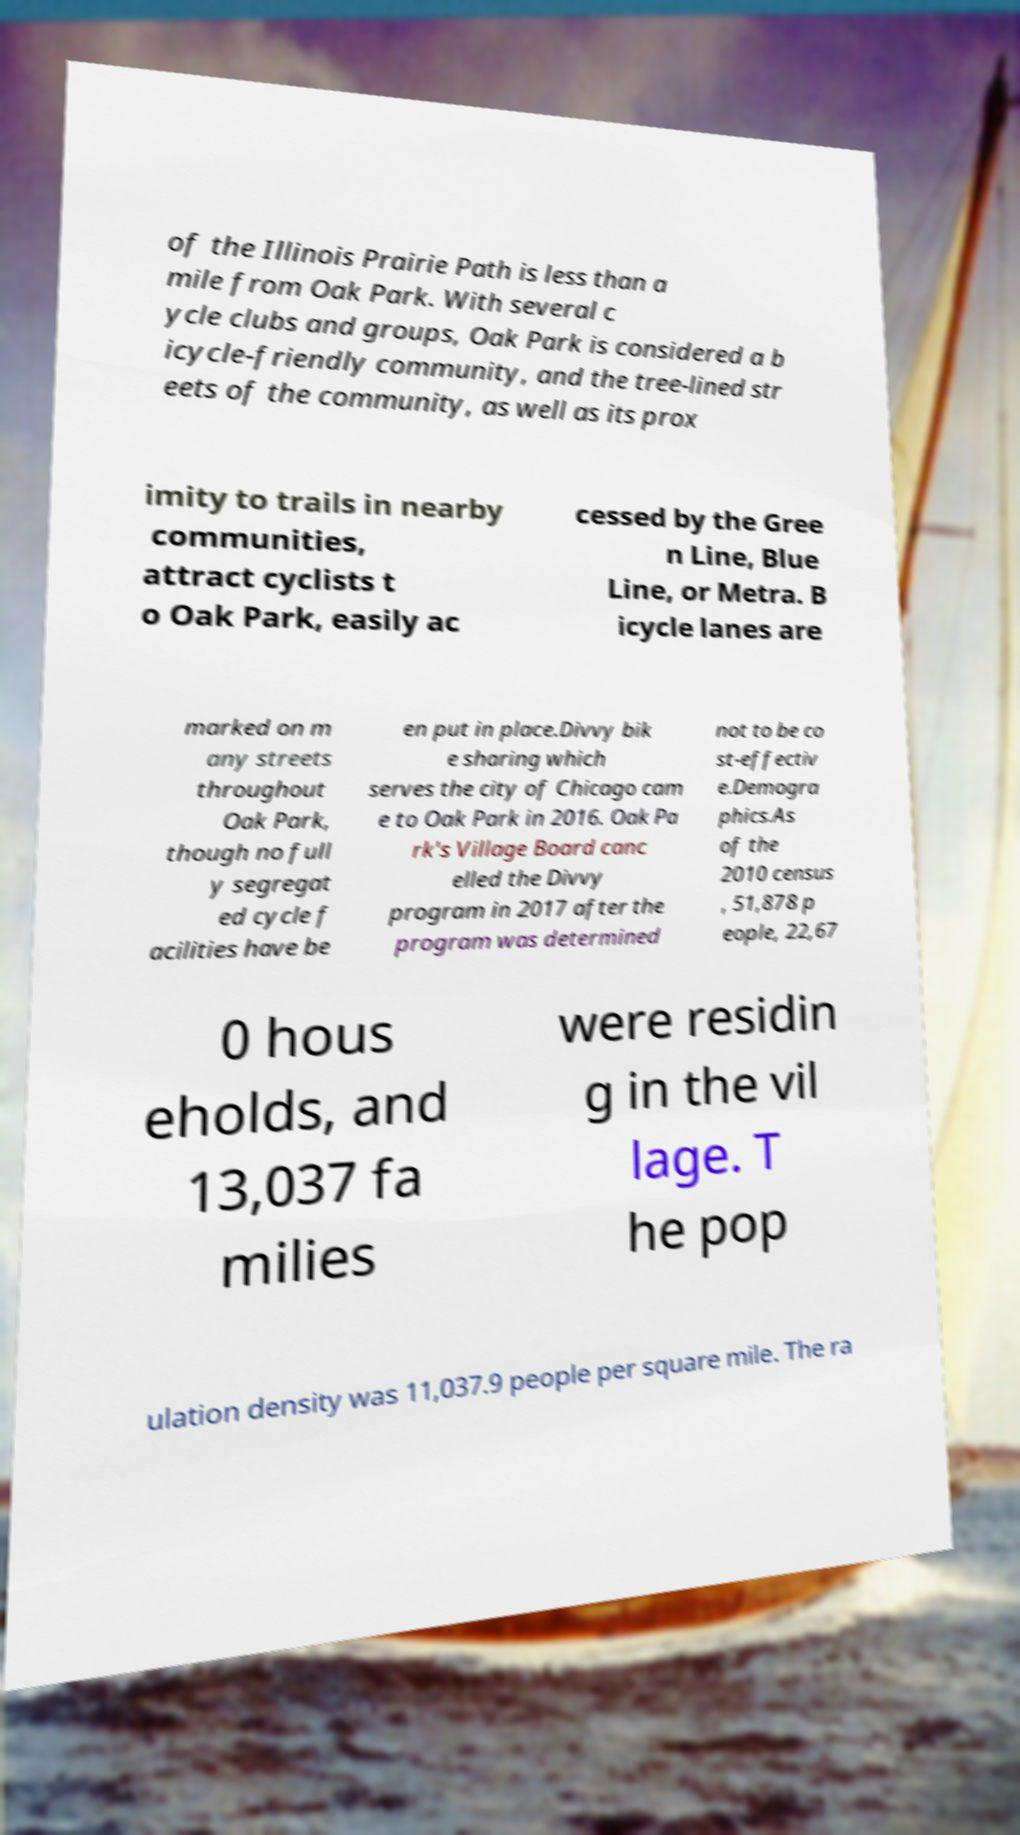Please identify and transcribe the text found in this image. of the Illinois Prairie Path is less than a mile from Oak Park. With several c ycle clubs and groups, Oak Park is considered a b icycle-friendly community, and the tree-lined str eets of the community, as well as its prox imity to trails in nearby communities, attract cyclists t o Oak Park, easily ac cessed by the Gree n Line, Blue Line, or Metra. B icycle lanes are marked on m any streets throughout Oak Park, though no full y segregat ed cycle f acilities have be en put in place.Divvy bik e sharing which serves the city of Chicago cam e to Oak Park in 2016. Oak Pa rk's Village Board canc elled the Divvy program in 2017 after the program was determined not to be co st-effectiv e.Demogra phics.As of the 2010 census , 51,878 p eople, 22,67 0 hous eholds, and 13,037 fa milies were residin g in the vil lage. T he pop ulation density was 11,037.9 people per square mile. The ra 